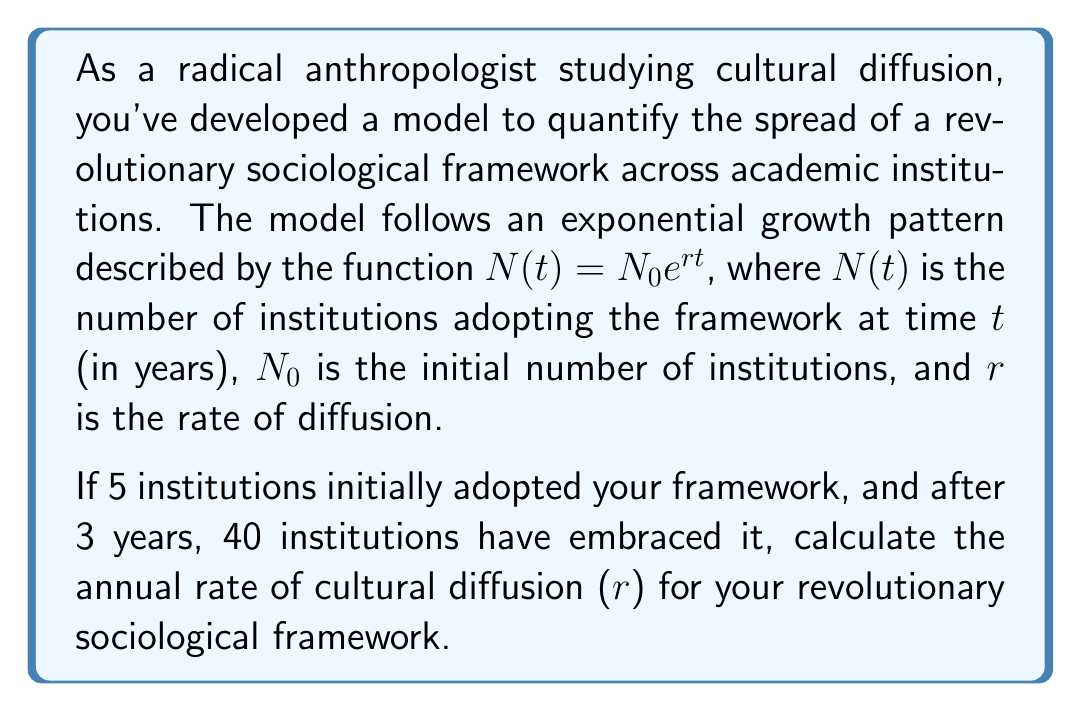Help me with this question. To solve this problem, we'll use the exponential growth model and the given information to find the rate of diffusion ($r$).

Given:
- Initial number of institutions: $N_0 = 5$
- Number of institutions after 3 years: $N(3) = 40$
- Time period: $t = 3$ years

We'll use the exponential growth formula:
$$N(t) = N_0 e^{rt}$$

Substituting the known values:
$$40 = 5e^{3r}$$

To solve for $r$, we'll follow these steps:

1) Divide both sides by 5:
   $$\frac{40}{5} = e^{3r}$$
   $$8 = e^{3r}$$

2) Take the natural logarithm of both sides:
   $$\ln(8) = \ln(e^{3r})$$
   $$\ln(8) = 3r$$

3) Solve for $r$:
   $$r = \frac{\ln(8)}{3}$$

4) Calculate the value:
   $$r = \frac{\ln(8)}{3} \approx 0.6931$$

Therefore, the annual rate of cultural diffusion is approximately 0.6931 or 69.31% per year.
Answer: $r \approx 0.6931$ or 69.31% per year 